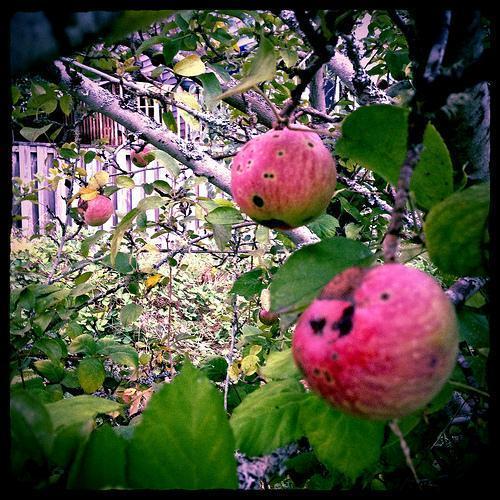How many apples are there?
Give a very brief answer. 4. 